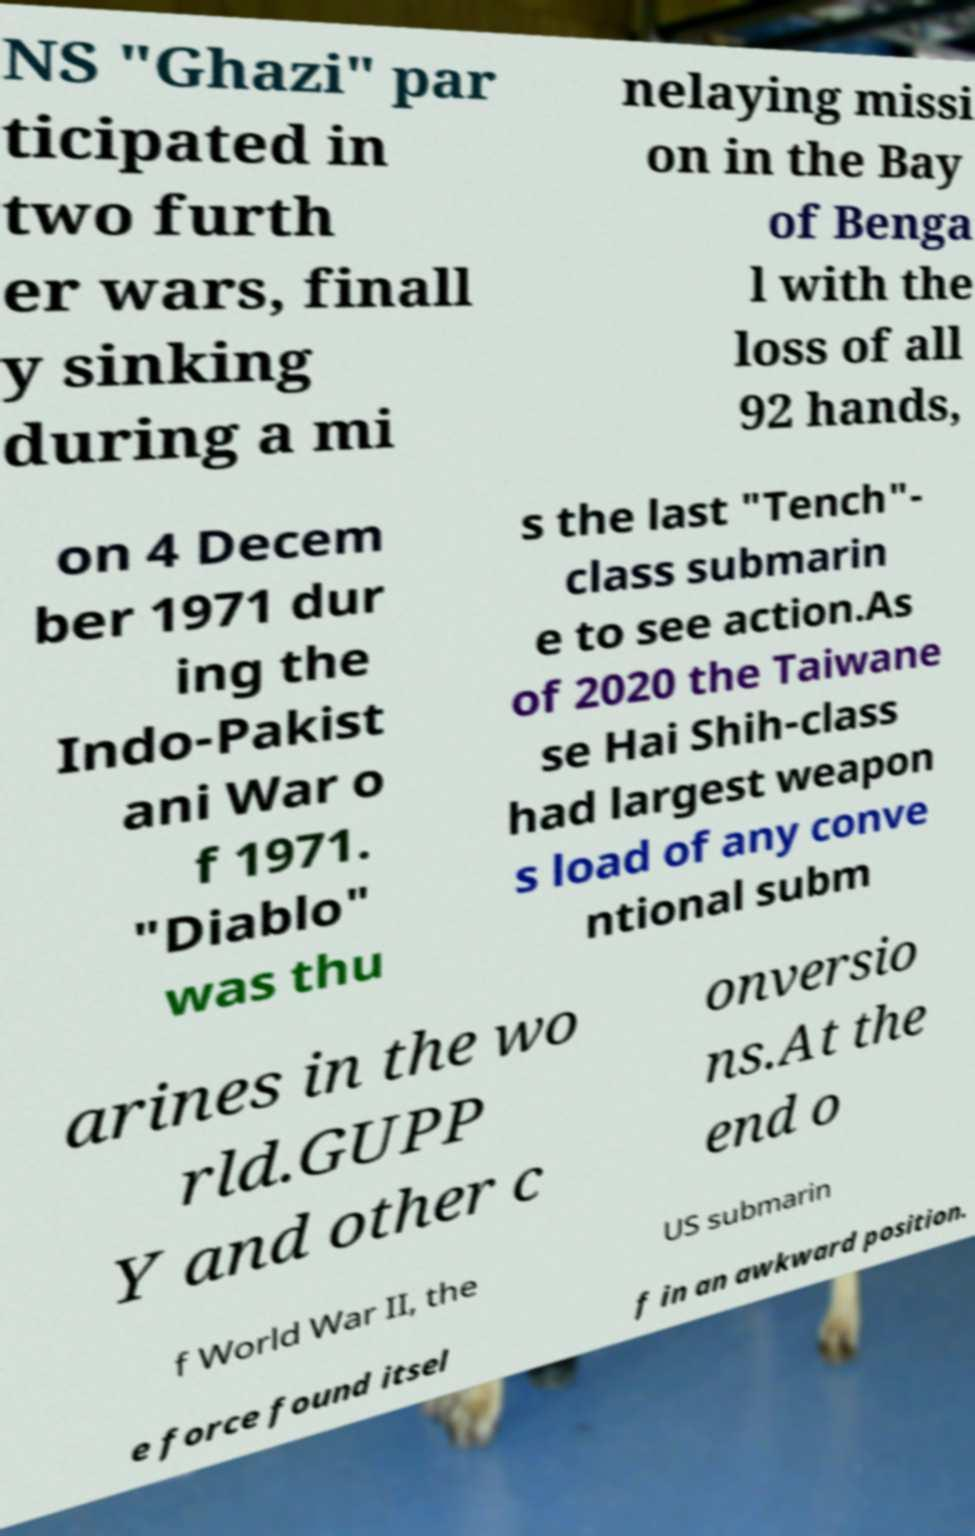There's text embedded in this image that I need extracted. Can you transcribe it verbatim? NS "Ghazi" par ticipated in two furth er wars, finall y sinking during a mi nelaying missi on in the Bay of Benga l with the loss of all 92 hands, on 4 Decem ber 1971 dur ing the Indo-Pakist ani War o f 1971. "Diablo" was thu s the last "Tench"- class submarin e to see action.As of 2020 the Taiwane se Hai Shih-class had largest weapon s load of any conve ntional subm arines in the wo rld.GUPP Y and other c onversio ns.At the end o f World War II, the US submarin e force found itsel f in an awkward position. 